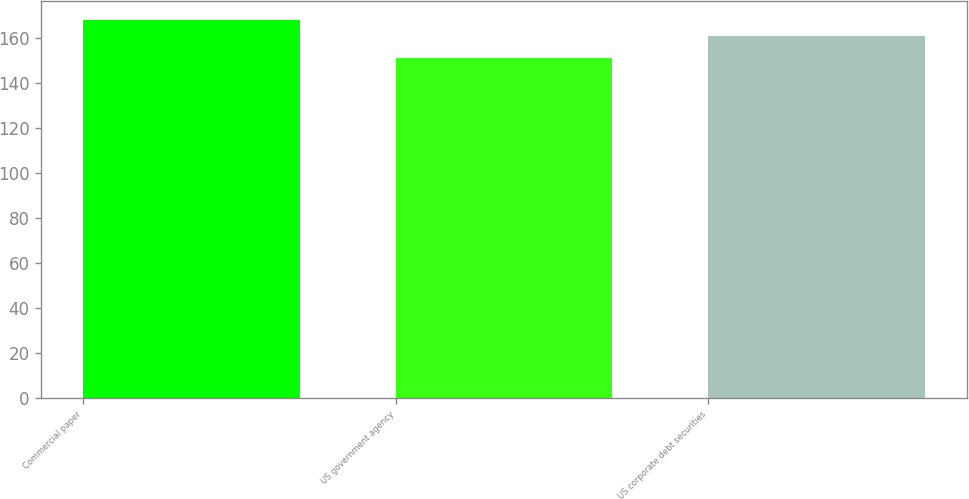Convert chart to OTSL. <chart><loc_0><loc_0><loc_500><loc_500><bar_chart><fcel>Commercial paper<fcel>US government agency<fcel>US corporate debt securities<nl><fcel>168<fcel>151<fcel>161<nl></chart> 